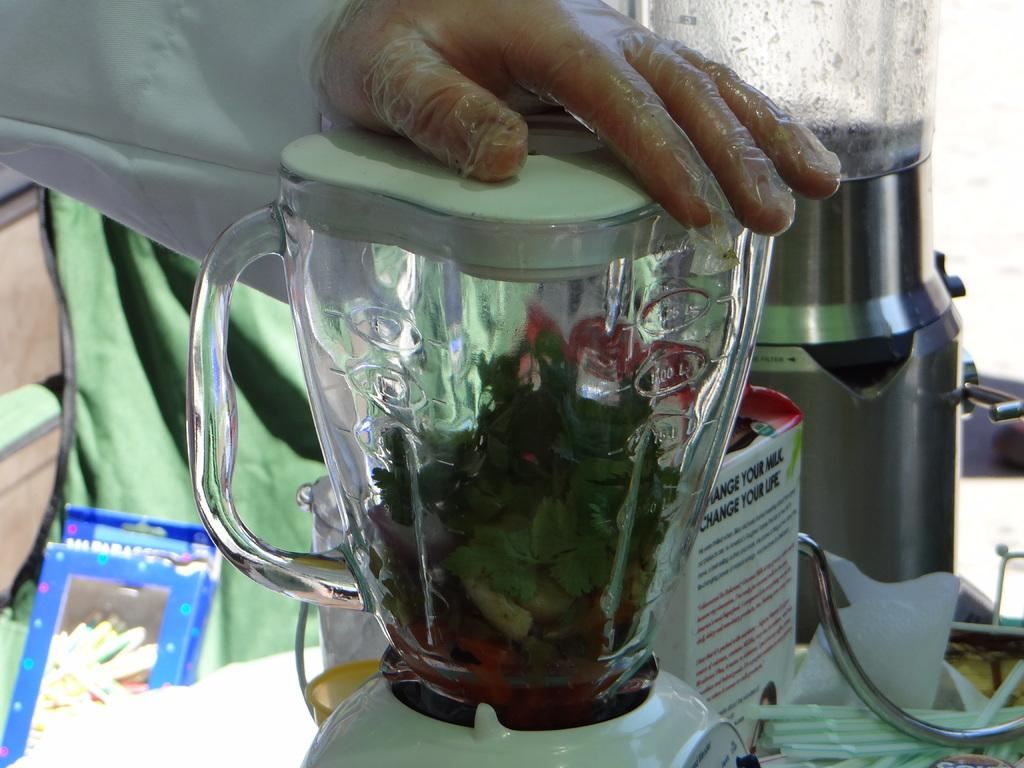<image>
Render a clear and concise summary of the photo. A man holding the top of a blender that says Change your life on the side. 